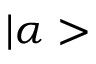Convert formula to latex. <formula><loc_0><loc_0><loc_500><loc_500>| \alpha ></formula> 